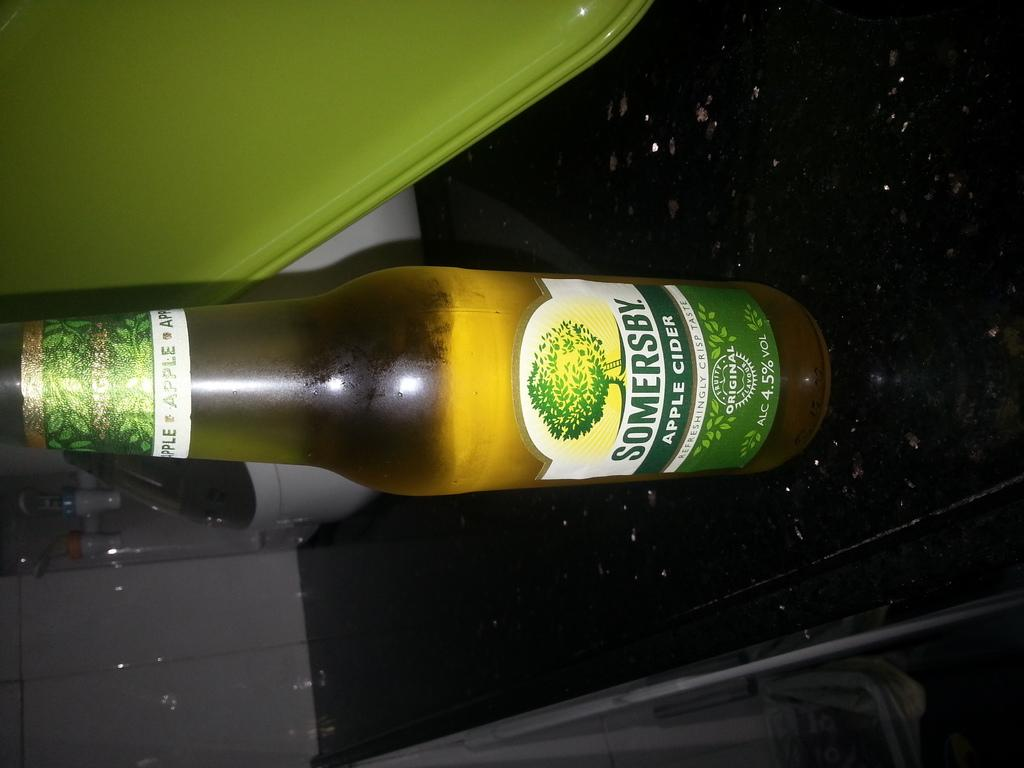<image>
Present a compact description of the photo's key features. The alcoholic drink here is Somersby apple cider 